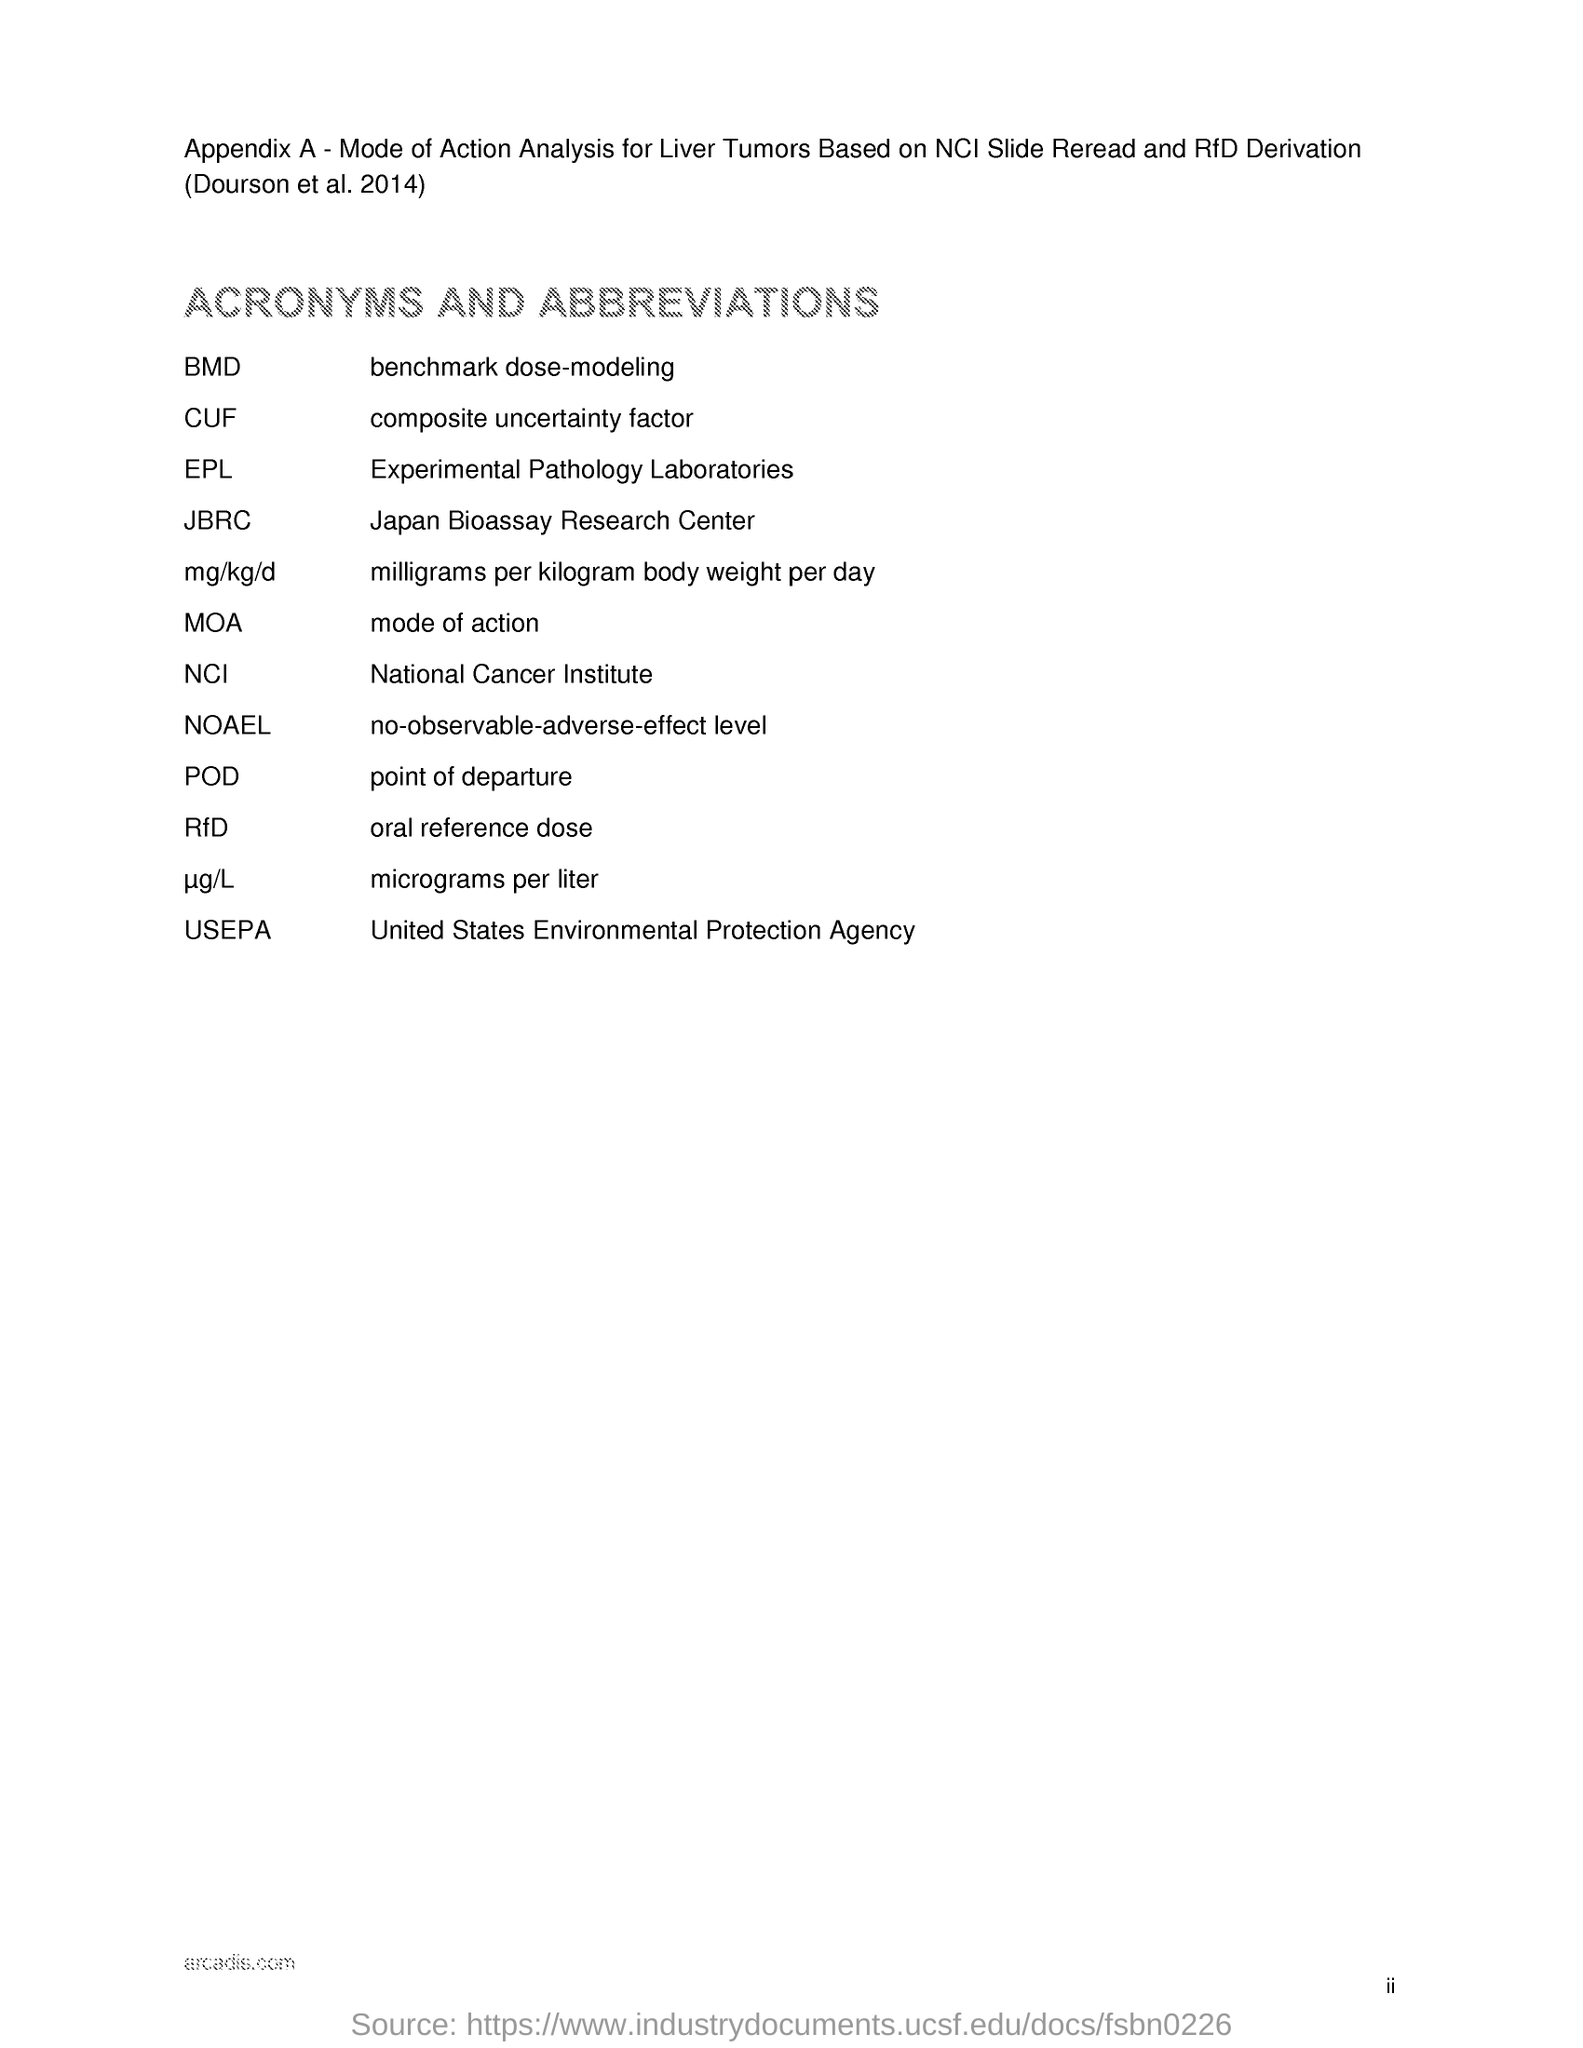What is in the appendix a?
Your answer should be very brief. Mode of Action Analysis for Liver Tumors Based on NCI Slide Reread and RfD Derivation. 